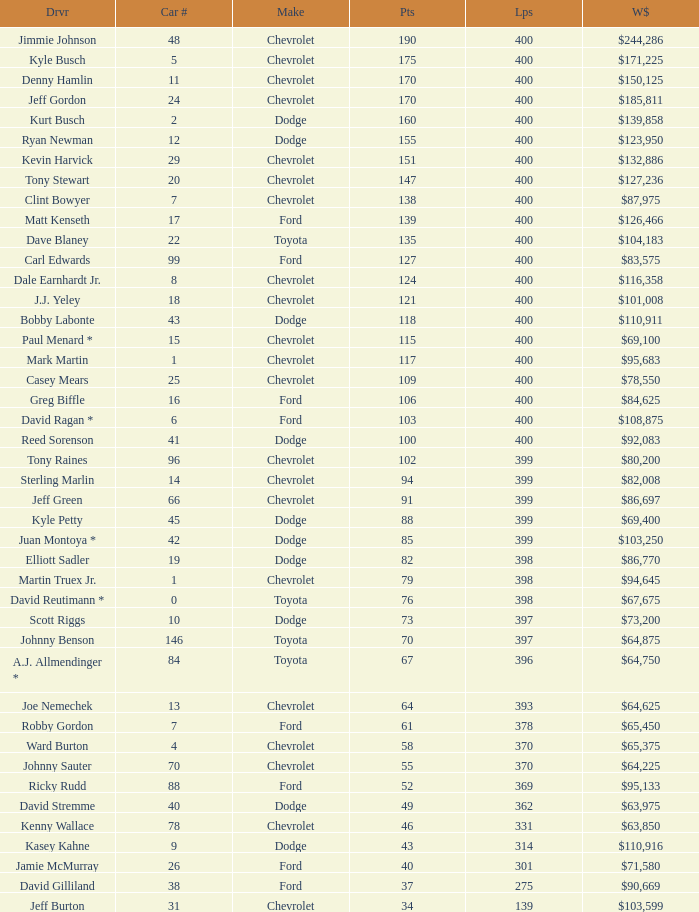What is the car number that has less than 369 laps for a Dodge with more than 49 points? None. 